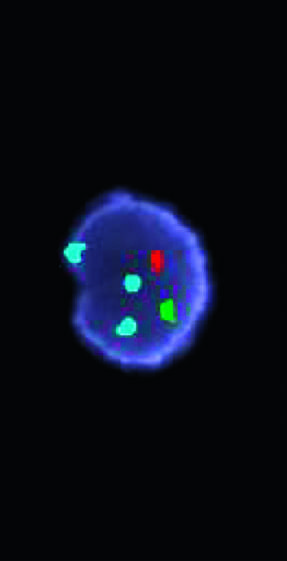how many different fluorescent probes have been used in a fish cocktail?
Answer the question using a single word or phrase. Three 